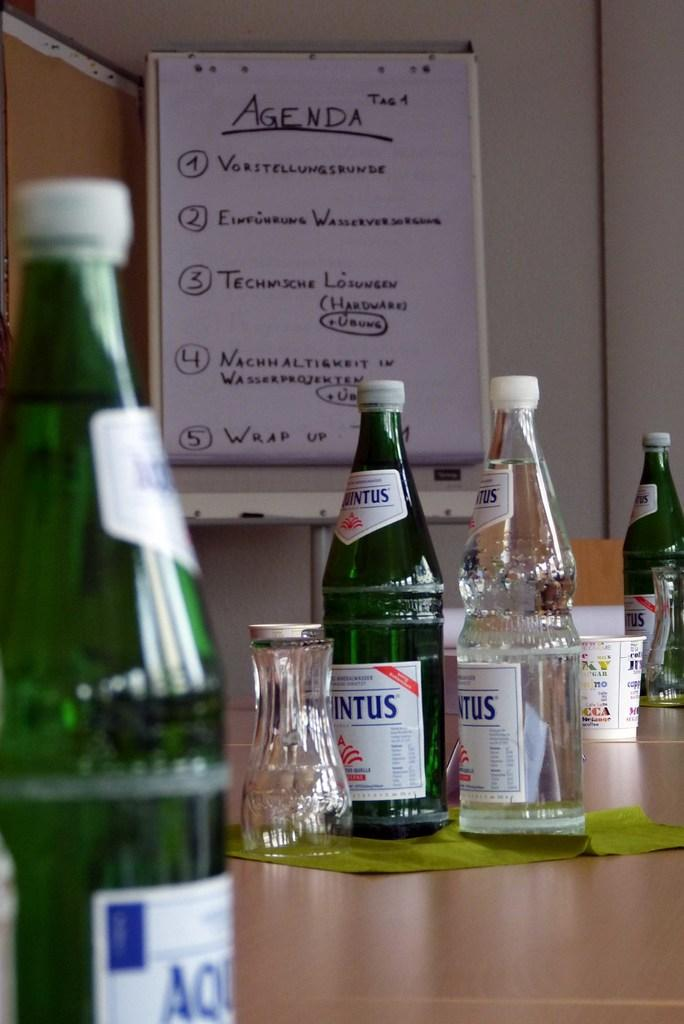<image>
Relay a brief, clear account of the picture shown. Various glass bottles are spread across the counter over tops of it an agenda is clipped up. 